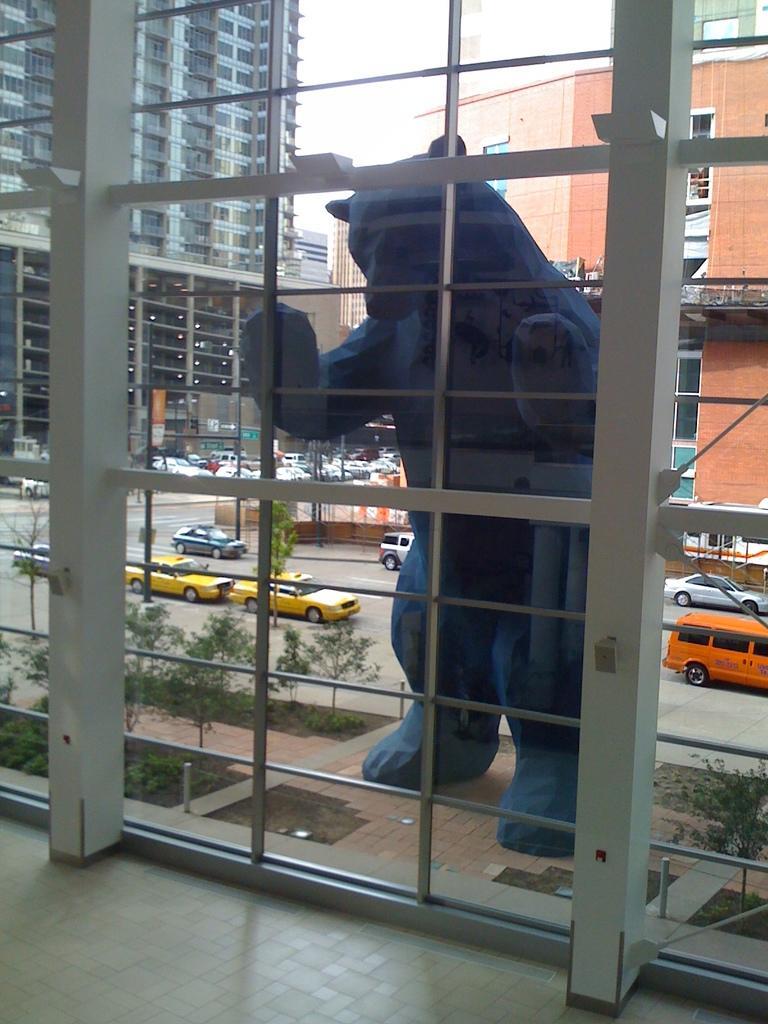Describe this image in one or two sentences. Through the glass outside view is visible. In this picture we can see the buildings, boards, vehicles, poles, road, statue, objects, trees and plants. At the bottom portion of the picture we can see the floor. 